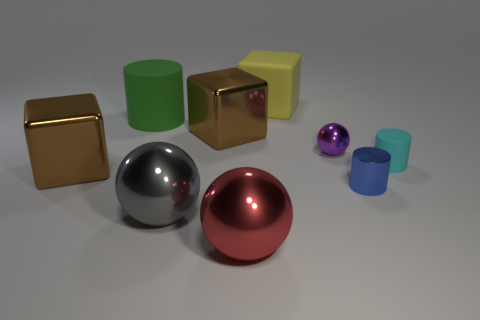There is a blue thing that is the same material as the tiny ball; what is its shape?
Your answer should be compact. Cylinder. How many things are metal cylinders or cyan matte cylinders?
Your answer should be compact. 2. What is the material of the small object right of the small blue metallic cylinder behind the big gray thing?
Give a very brief answer. Rubber. Are there any tiny gray balls made of the same material as the tiny purple object?
Offer a terse response. No. There is a tiny thing in front of the brown thing in front of the matte cylinder in front of the tiny metallic ball; what shape is it?
Ensure brevity in your answer.  Cylinder. What is the large yellow cube made of?
Your answer should be very brief. Rubber. There is a cube that is made of the same material as the large green cylinder; what is its color?
Your response must be concise. Yellow. Is there a purple sphere behind the sphere left of the red shiny thing?
Keep it short and to the point. Yes. How many other things are there of the same shape as the big yellow rubber thing?
Offer a very short reply. 2. There is a small metal object that is in front of the small sphere; does it have the same shape as the brown thing to the left of the big gray shiny ball?
Provide a succinct answer. No. 